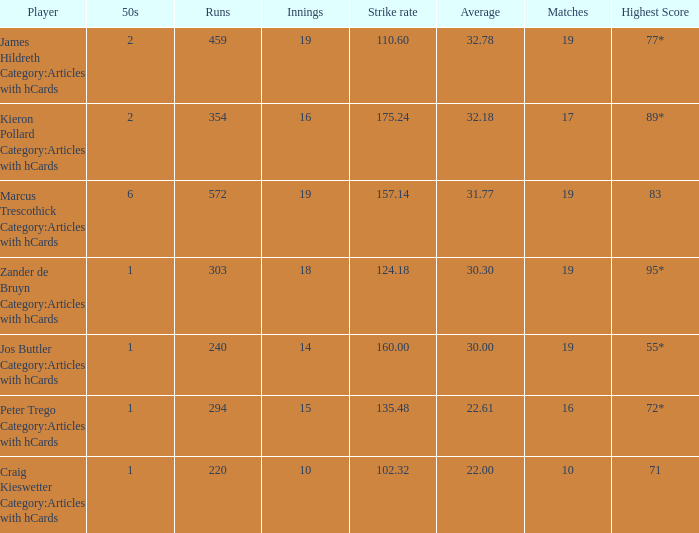What is the strike rate for the player with an average of 32.78? 110.6. 